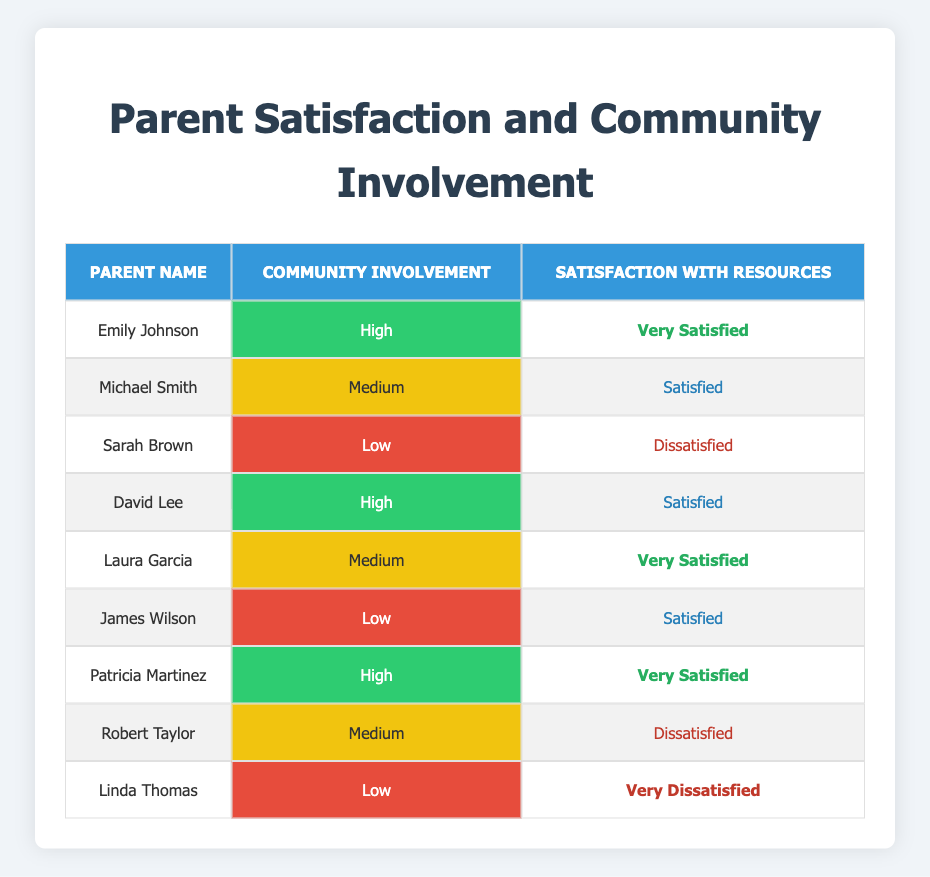What is the satisfaction level of Emily Johnson? In the table, we can find Emily Johnson in the first row with the corresponding satisfaction level noted as "Very Satisfied."
Answer: Very Satisfied How many parents have high community involvement? By examining the table, we identify three parents with "High" community involvement: Emily Johnson, David Lee, and Patricia Martinez.
Answer: 3 What percentage of parents with low community involvement are satisfied with the resources? There are three parents with low community involvement, and among them, two (Sarah Brown and James Wilson) are "Satisfied." To find the percentage, divide the number of satisfied parents by the total number of parents in this category: (2/3) * 100 = 66.67%.
Answer: 66.67% Is there a parent who is very dissatisfied and has low community involvement? Looking at the table, we can see that Linda Thomas is listed with "Low" community involvement and her satisfaction level is "Very Dissatisfied." This confirms the statement is true.
Answer: Yes What is the average satisfaction level among parents with medium community involvement? There are three parents with medium involvement: Michael Smith (Satisfied), Laura Garcia (Very Satisfied), and Robert Taylor (Dissatisfied). Convert the satisfaction levels to a numeric scale: Very Satisfied = 3, Satisfied = 2, Dissatisfied = 1. The sum is 2 + 3 + 1 = 6 and there are 3 parents, so the average is 6/3 = 2.
Answer: 2 Do all parents with high community involvement express satisfaction with resources? The table shows that among the three parents with high involvement, two are "Very Satisfied" and one is "Satisfied," indicating they all express satisfaction. Thus, the answer is yes.
Answer: Yes What is the total number of dissatisfied parents? In the table, we identify two dissatisfied parents: Sarah Brown and Robert Taylor, while Linda Thomas is very dissatisfied. Summing these gives us three dissatisfied parents.
Answer: 3 How many parents are very satisfied and have high community involvement? Referring to the table, we find that there are two parents with high involvement who are also very satisfied: Emily Johnson and Patricia Martinez.
Answer: 2 What is the difference in satisfaction levels between low and high community involvement groups? In low involvement, Sarah Brown is "Dissatisfied" (1), James Wilson is "Satisfied" (2), and Linda Thomas is "Very Dissatisfied" (0). The average for low is (0+1+2)/3 = 1. For high involvement, Emily Johnson and Patricia Martinez are "Very Satisfied" (3), and David Lee is "Satisfied" (2), resulting in an average of (3+2+3)/3 = 2. So, the difference is 2 - 1 = 1.
Answer: 1 